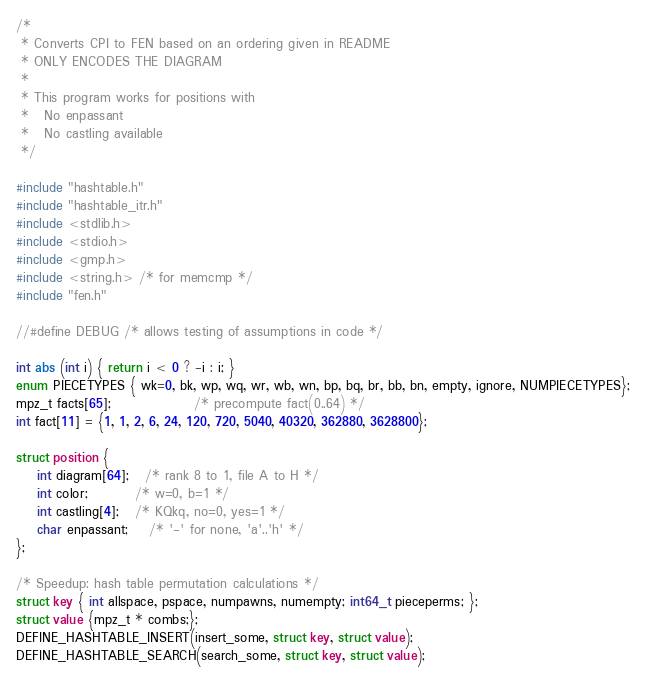<code> <loc_0><loc_0><loc_500><loc_500><_C_>/*
 * Converts CPI to FEN based on an ordering given in README
 * ONLY ENCODES THE DIAGRAM
 *
 * This program works for positions with
 *   No enpassant
 *   No castling available
 */

#include "hashtable.h"
#include "hashtable_itr.h"
#include <stdlib.h>
#include <stdio.h>
#include <gmp.h>
#include <string.h> /* for memcmp */
#include "fen.h"

//#define DEBUG /* allows testing of assumptions in code */

int abs (int i) { return i < 0 ? -i : i; }
enum PIECETYPES { wk=0, bk, wp, wq, wr, wb, wn, bp, bq, br, bb, bn, empty, ignore, NUMPIECETYPES}; 
mpz_t facts[65];                /* precompute fact(0..64) */
int fact[11] = {1, 1, 2, 6, 24, 120, 720, 5040, 40320, 362880, 3628800};

struct position {
    int diagram[64];   /* rank 8 to 1, file A to H */
    int color;         /* w=0, b=1 */
    int castling[4];   /* KQkq, no=0, yes=1 */
    char enpassant;    /* '-' for none, 'a'..'h' */
};

/* Speedup: hash table permutation calculations */
struct key { int allspace, pspace, numpawns, numempty; int64_t pieceperms; };
struct value {mpz_t * combs;};
DEFINE_HASHTABLE_INSERT(insert_some, struct key, struct value);
DEFINE_HASHTABLE_SEARCH(search_some, struct key, struct value);
</code> 